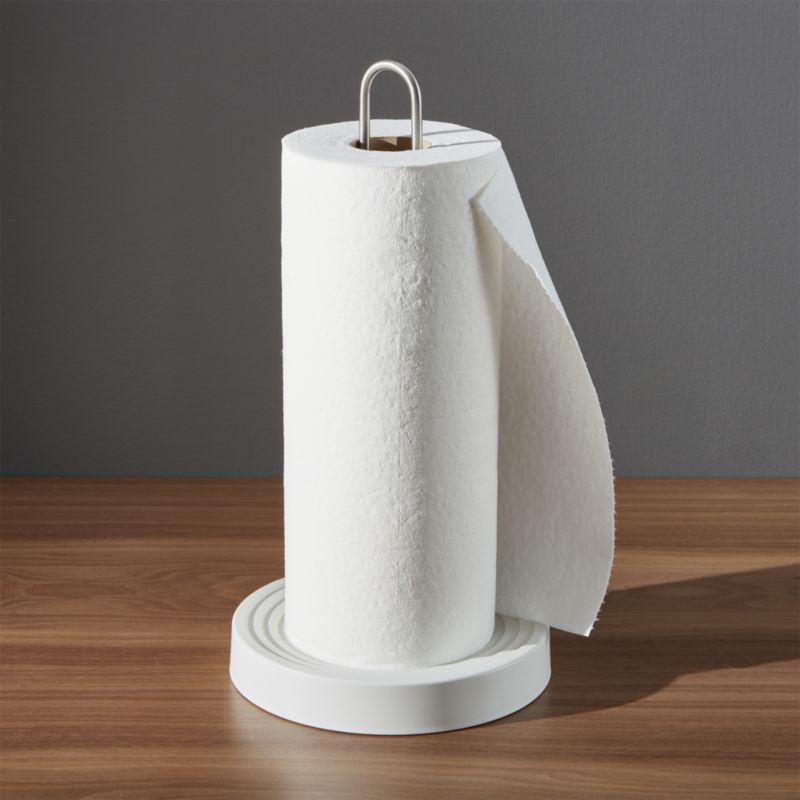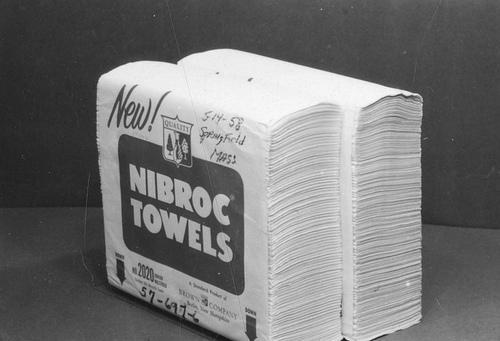The first image is the image on the left, the second image is the image on the right. Evaluate the accuracy of this statement regarding the images: "there are at seven rolls total". Is it true? Answer yes or no. No. 